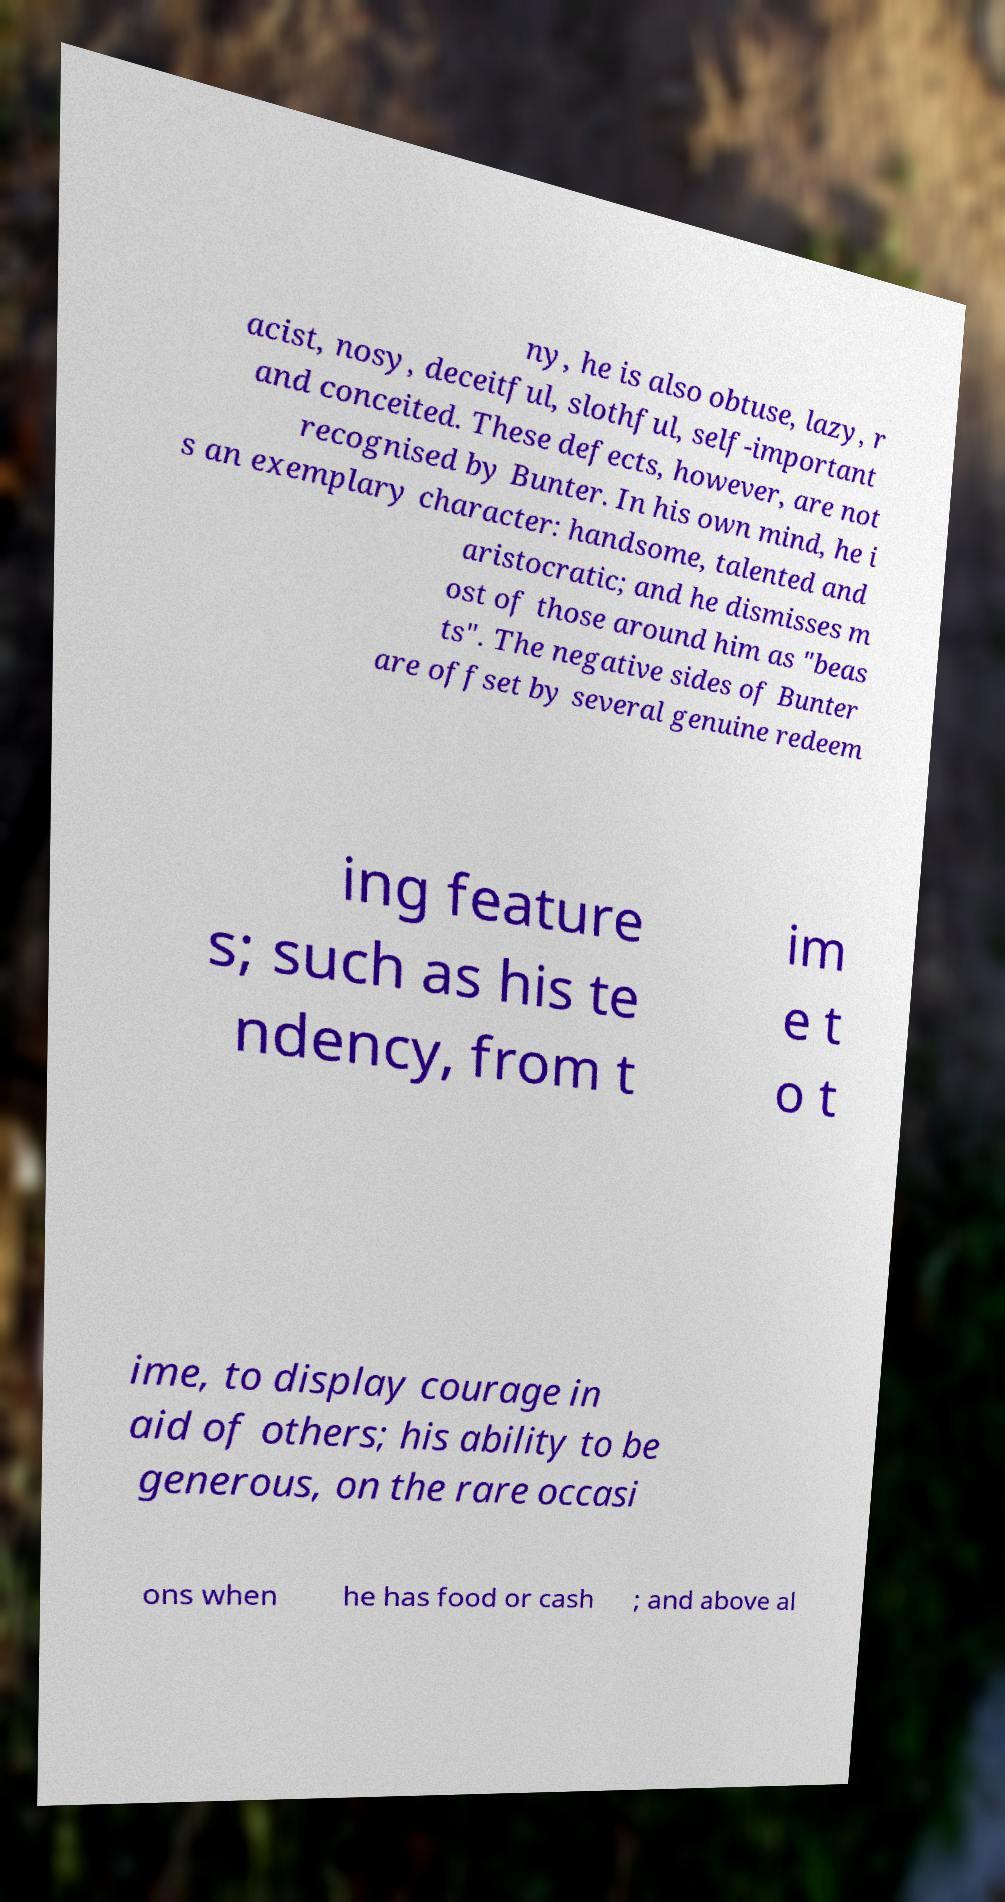What messages or text are displayed in this image? I need them in a readable, typed format. ny, he is also obtuse, lazy, r acist, nosy, deceitful, slothful, self-important and conceited. These defects, however, are not recognised by Bunter. In his own mind, he i s an exemplary character: handsome, talented and aristocratic; and he dismisses m ost of those around him as "beas ts". The negative sides of Bunter are offset by several genuine redeem ing feature s; such as his te ndency, from t im e t o t ime, to display courage in aid of others; his ability to be generous, on the rare occasi ons when he has food or cash ; and above al 